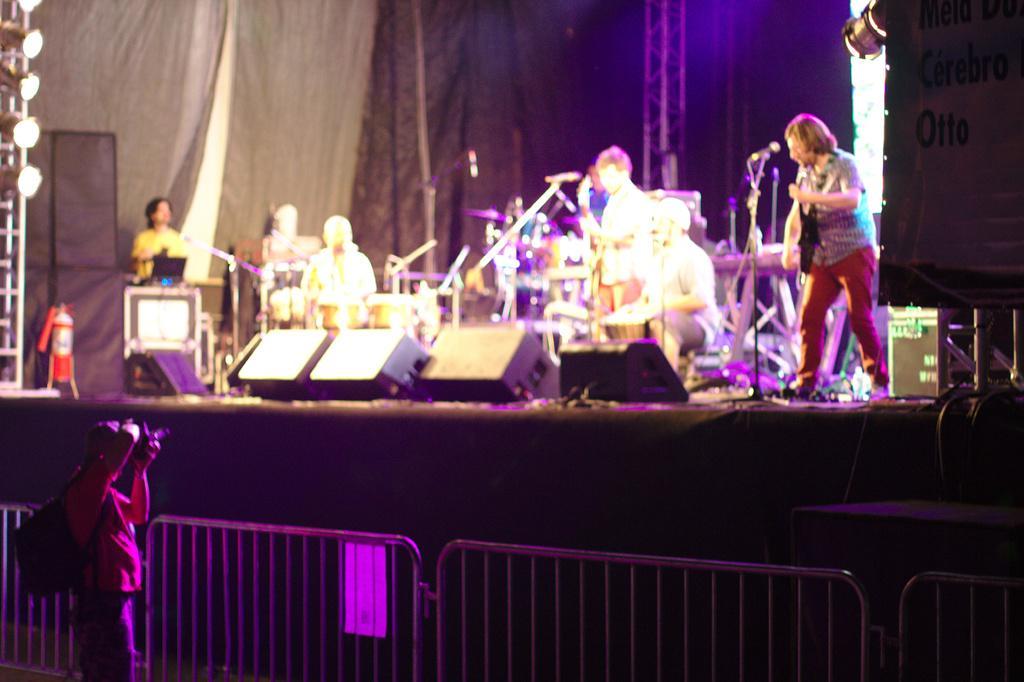Can you describe this image briefly? In this picture we can see a person playing drums, and here is the person is standing, and beside him a person is sitting, and at back a person is standing and playing guitar, and here is the microphone ,and here is the fire extinguisher on the stage ,and at down a person is taking a picture, and here are the lights. 